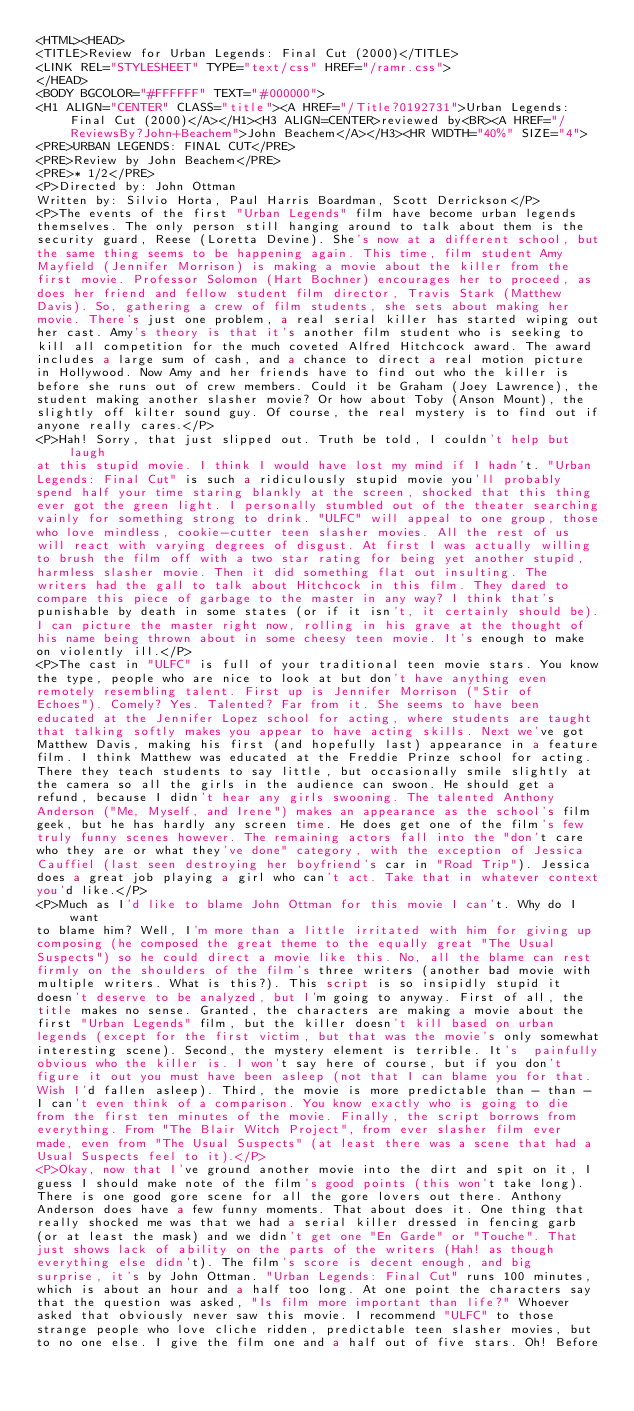<code> <loc_0><loc_0><loc_500><loc_500><_HTML_><HTML><HEAD>
<TITLE>Review for Urban Legends: Final Cut (2000)</TITLE>
<LINK REL="STYLESHEET" TYPE="text/css" HREF="/ramr.css">
</HEAD>
<BODY BGCOLOR="#FFFFFF" TEXT="#000000">
<H1 ALIGN="CENTER" CLASS="title"><A HREF="/Title?0192731">Urban Legends: Final Cut (2000)</A></H1><H3 ALIGN=CENTER>reviewed by<BR><A HREF="/ReviewsBy?John+Beachem">John Beachem</A></H3><HR WIDTH="40%" SIZE="4">
<PRE>URBAN LEGENDS: FINAL CUT</PRE>
<PRE>Review by John Beachem</PRE>
<PRE>* 1/2</PRE>
<P>Directed by: John Ottman
Written by: Silvio Horta, Paul Harris Boardman, Scott Derrickson</P>
<P>The events of the first "Urban Legends" film have become urban legends 
themselves. The only person still hanging around to talk about them is the 
security guard, Reese (Loretta Devine). She's now at a different school, but 
the same thing seems to be happening again. This time, film student Amy 
Mayfield (Jennifer Morrison) is making a movie about the killer from the 
first movie. Professor Solomon (Hart Bochner) encourages her to proceed, as 
does her friend and fellow student film director, Travis Stark (Matthew 
Davis). So, gathering a crew of film students, she sets about making her 
movie. There's just one problem, a real serial killer has started wiping out 
her cast. Amy's theory is that it's another film student who is seeking to 
kill all competition for the much coveted Alfred Hitchcock award. The award 
includes a large sum of cash, and a chance to direct a real motion picture 
in Hollywood. Now Amy and her friends have to find out who the killer is 
before she runs out of crew members. Could it be Graham (Joey Lawrence), the 
student making another slasher movie? Or how about Toby (Anson Mount), the 
slightly off kilter sound guy. Of course, the real mystery is to find out if 
anyone really cares.</P>
<P>Hah! Sorry, that just slipped out. Truth be told, I couldn't help but laugh 
at this stupid movie. I think I would have lost my mind if I hadn't. "Urban 
Legends: Final Cut" is such a ridiculously stupid movie you'll probably 
spend half your time staring blankly at the screen, shocked that this thing 
ever got the green light. I personally stumbled out of the theater searching 
vainly for something strong to drink. "ULFC" will appeal to one group, those 
who love mindless, cookie-cutter teen slasher movies. All the rest of us 
will react with varying degrees of disgust. At first I was actually willing 
to brush the film off with a two star rating for being yet another stupid, 
harmless slasher movie. Then it did something flat out insulting. The 
writers had the gall to talk about Hitchcock in this film. They dared to 
compare this piece of garbage to the master in any way? I think that's 
punishable by death in some states (or if it isn't, it certainly should be). 
I can picture the master right now, rolling in his grave at the thought of 
his name being thrown about in some cheesy teen movie. It's enough to make 
on violently ill.</P>
<P>The cast in "ULFC" is full of your traditional teen movie stars. You know 
the type, people who are nice to look at but don't have anything even 
remotely resembling talent. First up is Jennifer Morrison ("Stir of 
Echoes"). Comely? Yes. Talented? Far from it. She seems to have been 
educated at the Jennifer Lopez school for acting, where students are taught 
that talking softly makes you appear to have acting skills. Next we've got 
Matthew Davis, making his first (and hopefully last) appearance in a feature 
film. I think Matthew was educated at the Freddie Prinze school for acting. 
There they teach students to say little, but occasionally smile slightly at 
the camera so all the girls in the audience can swoon. He should get a 
refund, because I didn't hear any girls swooning. The talented Anthony 
Anderson ("Me, Myself, and Irene") makes an appearance as the school's film 
geek, but he has hardly any screen time. He does get one of the film's few 
truly funny scenes however. The remaining actors fall into the "don't care 
who they are or what they've done" category, with the exception of Jessica 
Cauffiel (last seen destroying her boyfriend's car in "Road Trip"). Jessica 
does a great job playing a girl who can't act. Take that in whatever context 
you'd like.</P>
<P>Much as I'd like to blame John Ottman for this movie I can't. Why do I want 
to blame him? Well, I'm more than a little irritated with him for giving up 
composing (he composed the great theme to the equally great "The Usual 
Suspects") so he could direct a movie like this. No, all the blame can rest 
firmly on the shoulders of the film's three writers (another bad movie with 
multiple writers. What is this?). This script is so insipidly stupid it 
doesn't deserve to be analyzed, but I'm going to anyway. First of all, the 
title makes no sense. Granted, the characters are making a movie about the 
first "Urban Legends" film, but the killer doesn't kill based on urban 
legends (except for the first victim, but that was the movie's only somewhat 
interesting scene). Second, the mystery element is terrible. It's  painfully 
obvious who the killer is. I won't say here of course, but if you don't 
figure it out you must have been asleep (not that I can blame you for that. 
Wish I'd fallen asleep). Third, the movie is more predictable than - than - 
I can't even think of a comparison. You know exactly who is going to die 
from the first ten minutes of the movie. Finally, the script borrows from 
everything. From "The Blair Witch Project", from ever slasher film ever 
made, even from "The Usual Suspects" (at least there was a scene that had a 
Usual Suspects feel to it).</P>
<P>Okay, now that I've ground another movie into the dirt and spit on it, I 
guess I should make note of the film's good points (this won't take long). 
There is one good gore scene for all the gore lovers out there. Anthony 
Anderson does have a few funny moments. That about does it. One thing that 
really shocked me was that we had a serial killer dressed in fencing garb 
(or at least the mask) and we didn't get one "En Garde" or "Touche". That 
just shows lack of ability on the parts of the writers (Hah! as though 
everything else didn't). The film's score is decent enough, and big 
surprise, it's by John Ottman. "Urban Legends: Final Cut" runs 100 minutes, 
which is about an hour and a half too long. At one point the characters say 
that the question was asked, "Is film more important than life?" Whoever 
asked that obviously never saw this movie. I recommend "ULFC" to those 
strange people who love cliche ridden, predictable teen slasher movies, but 
to no one else. I give the film one and a half out of five stars. Oh! Before </code> 